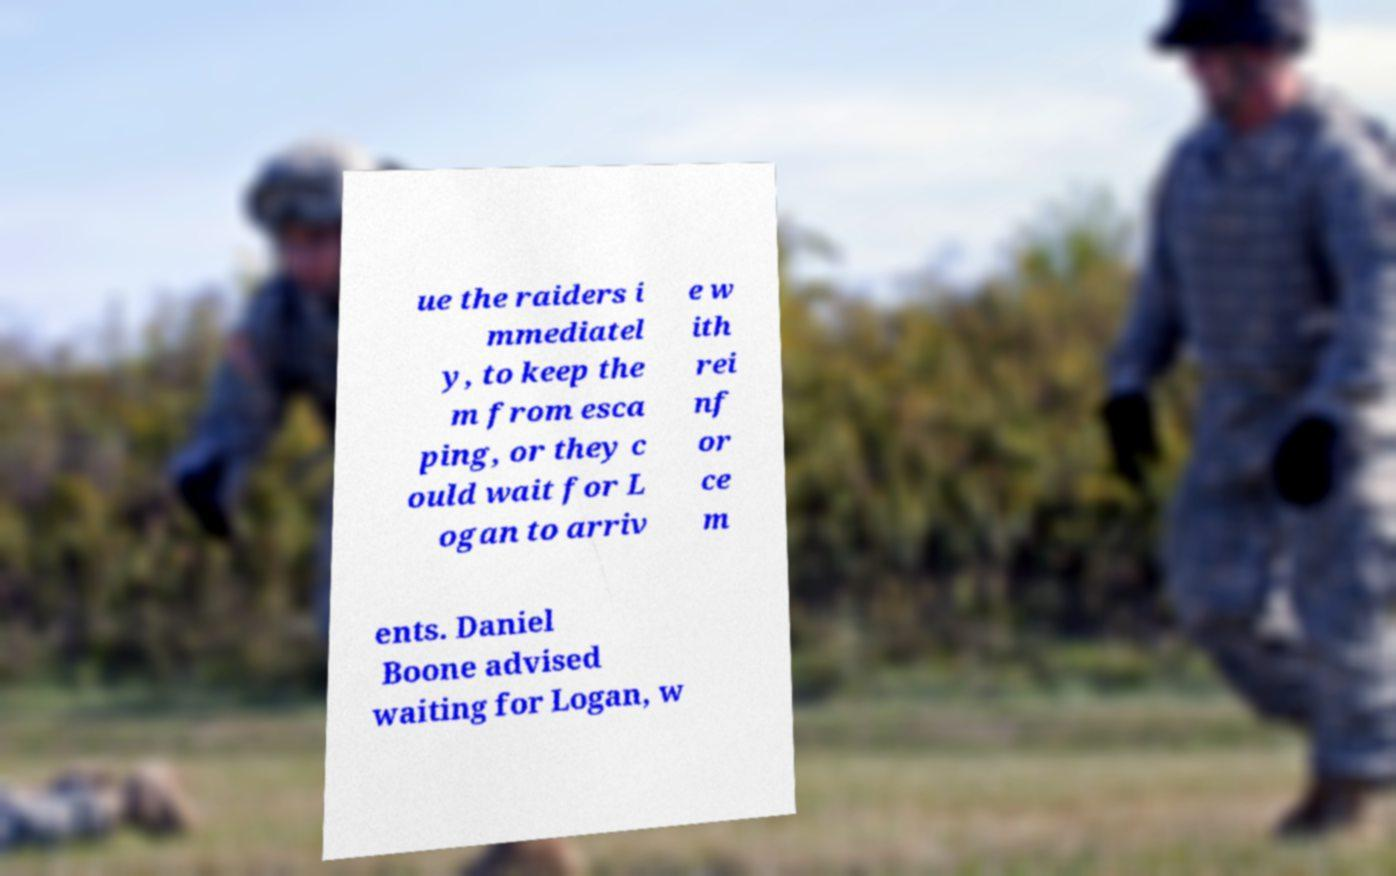Please identify and transcribe the text found in this image. ue the raiders i mmediatel y, to keep the m from esca ping, or they c ould wait for L ogan to arriv e w ith rei nf or ce m ents. Daniel Boone advised waiting for Logan, w 